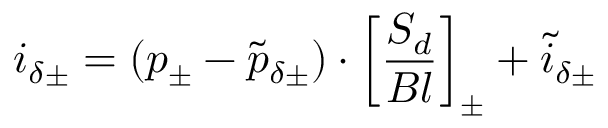Convert formula to latex. <formula><loc_0><loc_0><loc_500><loc_500>i _ { \delta \pm } = ( p _ { \pm } - \tilde { p } _ { \delta \pm } ) \cdot \left [ \frac { S _ { d } } { B l } \right ] _ { \pm } + \tilde { i } _ { \delta \pm }</formula> 